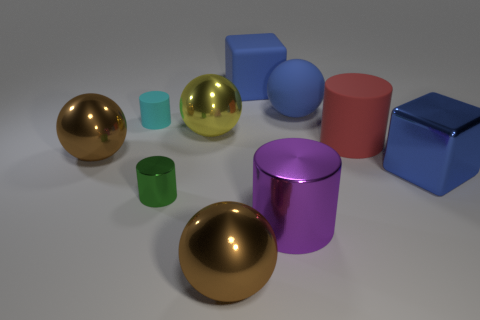Does the rubber cylinder to the left of the rubber block have the same size as the brown sphere in front of the green shiny cylinder?
Your answer should be compact. No. What is the material of the yellow object that is the same size as the blue ball?
Keep it short and to the point. Metal. There is a ball that is left of the big purple shiny object and behind the red rubber thing; what material is it?
Provide a short and direct response. Metal. Is there a purple shiny sphere?
Offer a terse response. No. There is a small metallic thing; is its color the same as the matte cylinder that is behind the big rubber cylinder?
Provide a succinct answer. No. There is a large sphere that is the same color as the big metallic cube; what is its material?
Give a very brief answer. Rubber. Are there any other things that are the same shape as the purple metal object?
Provide a short and direct response. Yes. What is the shape of the metallic object behind the red cylinder that is to the left of the big metal thing that is on the right side of the red matte thing?
Your response must be concise. Sphere. There is a tiny rubber thing; what shape is it?
Provide a short and direct response. Cylinder. The rubber object that is left of the blue rubber cube is what color?
Your answer should be compact. Cyan. 